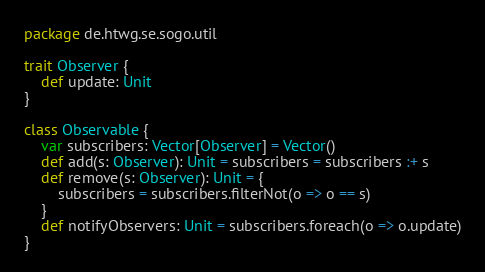<code> <loc_0><loc_0><loc_500><loc_500><_Scala_>package de.htwg.se.sogo.util

trait Observer {
    def update: Unit
}

class Observable {
    var subscribers: Vector[Observer] = Vector()
    def add(s: Observer): Unit = subscribers = subscribers :+ s
    def remove(s: Observer): Unit = {
        subscribers = subscribers.filterNot(o => o == s)
    }
    def notifyObservers: Unit = subscribers.foreach(o => o.update)
}
</code> 